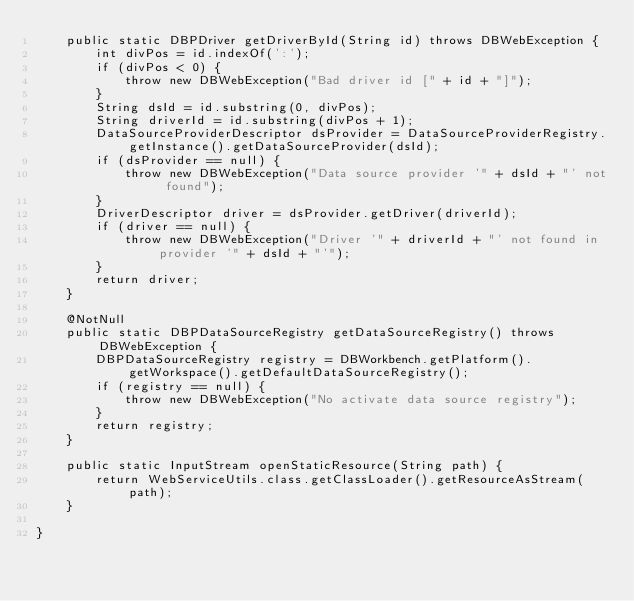<code> <loc_0><loc_0><loc_500><loc_500><_Java_>    public static DBPDriver getDriverById(String id) throws DBWebException {
        int divPos = id.indexOf(':');
        if (divPos < 0) {
            throw new DBWebException("Bad driver id [" + id + "]");
        }
        String dsId = id.substring(0, divPos);
        String driverId = id.substring(divPos + 1);
        DataSourceProviderDescriptor dsProvider = DataSourceProviderRegistry.getInstance().getDataSourceProvider(dsId);
        if (dsProvider == null) {
            throw new DBWebException("Data source provider '" + dsId + "' not found");
        }
        DriverDescriptor driver = dsProvider.getDriver(driverId);
        if (driver == null) {
            throw new DBWebException("Driver '" + driverId + "' not found in provider '" + dsId + "'");
        }
        return driver;
    }

    @NotNull
    public static DBPDataSourceRegistry getDataSourceRegistry() throws DBWebException {
        DBPDataSourceRegistry registry = DBWorkbench.getPlatform().getWorkspace().getDefaultDataSourceRegistry();
        if (registry == null) {
            throw new DBWebException("No activate data source registry");
        }
        return registry;
    }

    public static InputStream openStaticResource(String path) {
        return WebServiceUtils.class.getClassLoader().getResourceAsStream(path);
    }

}
</code> 